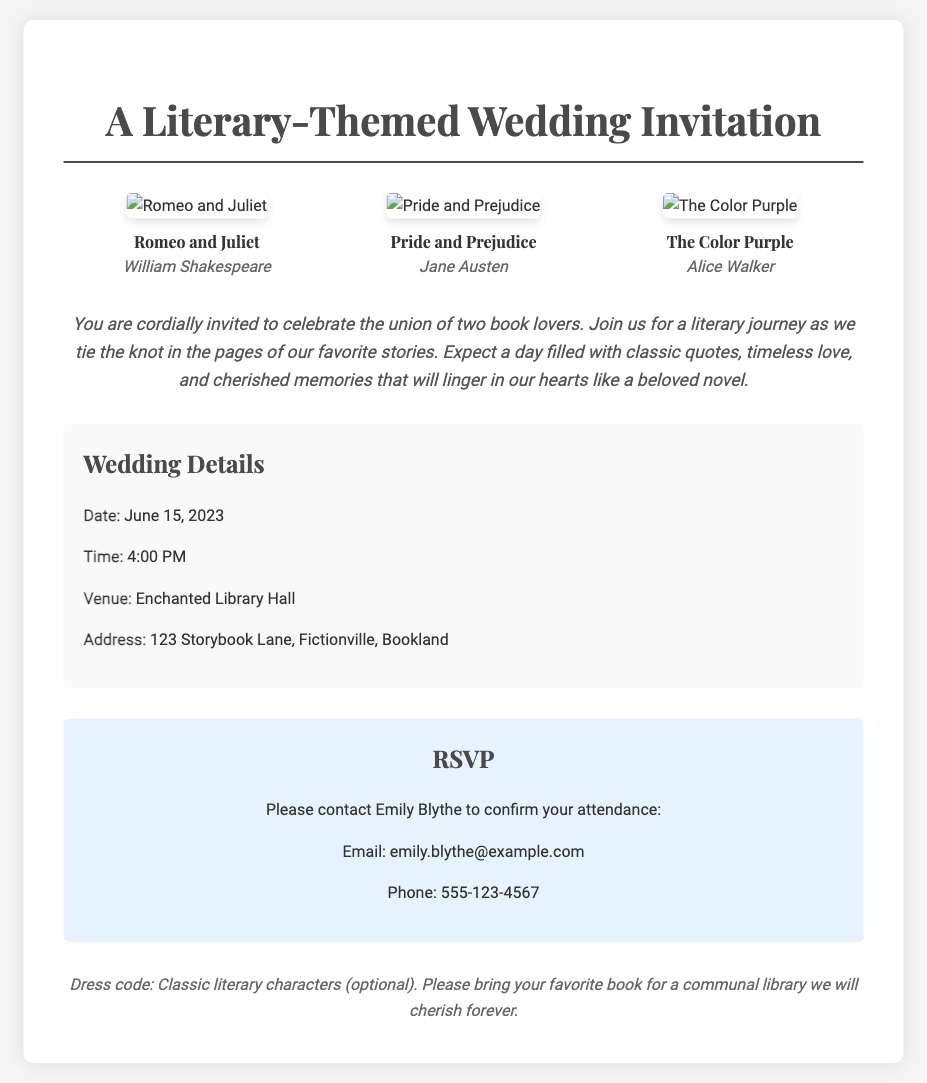What is the date of the wedding? The date is explicitly mentioned in the document under "Wedding Details."
Answer: June 15, 2023 What time does the wedding start? The time is listed in the "Wedding Details" section of the invitation.
Answer: 4:00 PM What is the venue name? The venue is provided in the "Wedding Details" section.
Answer: Enchanted Library Hall Who is the author of "The Color Purple"? The author is mentioned in the book cover section of the invitation.
Answer: Alice Walker What should guests bring for the communal library? The invitation mentions what guests should bring in the additional notes section.
Answer: your favorite book What is the dress code for the wedding? The dress code is listed in the additional notes section.
Answer: Classic literary characters (optional) How can guests confirm their attendance? The RSVP section details how to contact to confirm attendance.
Answer: Email or Phone What are the names of the two book covers featured beside "Pride and Prejudice"? The other book covers are mentioned alongside "Pride and Prejudice" in the document.
Answer: Romeo and Juliet, The Color Purple Where is the venue located? The address is provided in the wedding details section.
Answer: 123 Storybook Lane, Fictionville, Bookland 